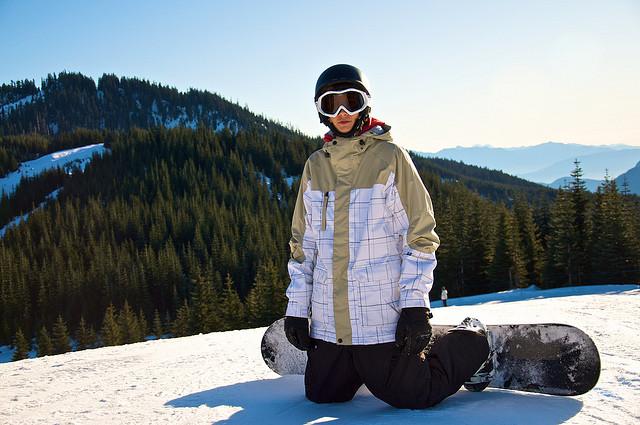Is this the customary way to snowboard?
Answer briefly. No. Where are the goggles?
Keep it brief. Face. What sport does this person look equipped for?
Write a very short answer. Snowboarding. 